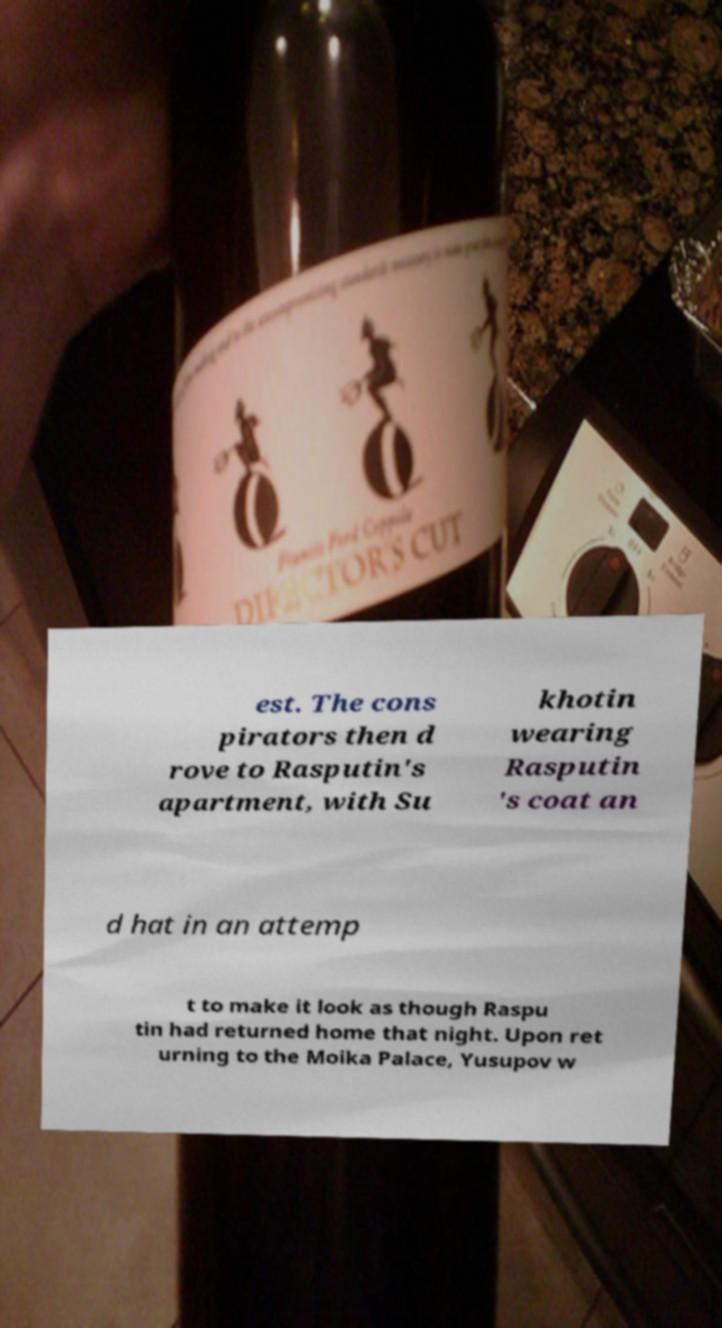Could you extract and type out the text from this image? est. The cons pirators then d rove to Rasputin's apartment, with Su khotin wearing Rasputin 's coat an d hat in an attemp t to make it look as though Raspu tin had returned home that night. Upon ret urning to the Moika Palace, Yusupov w 